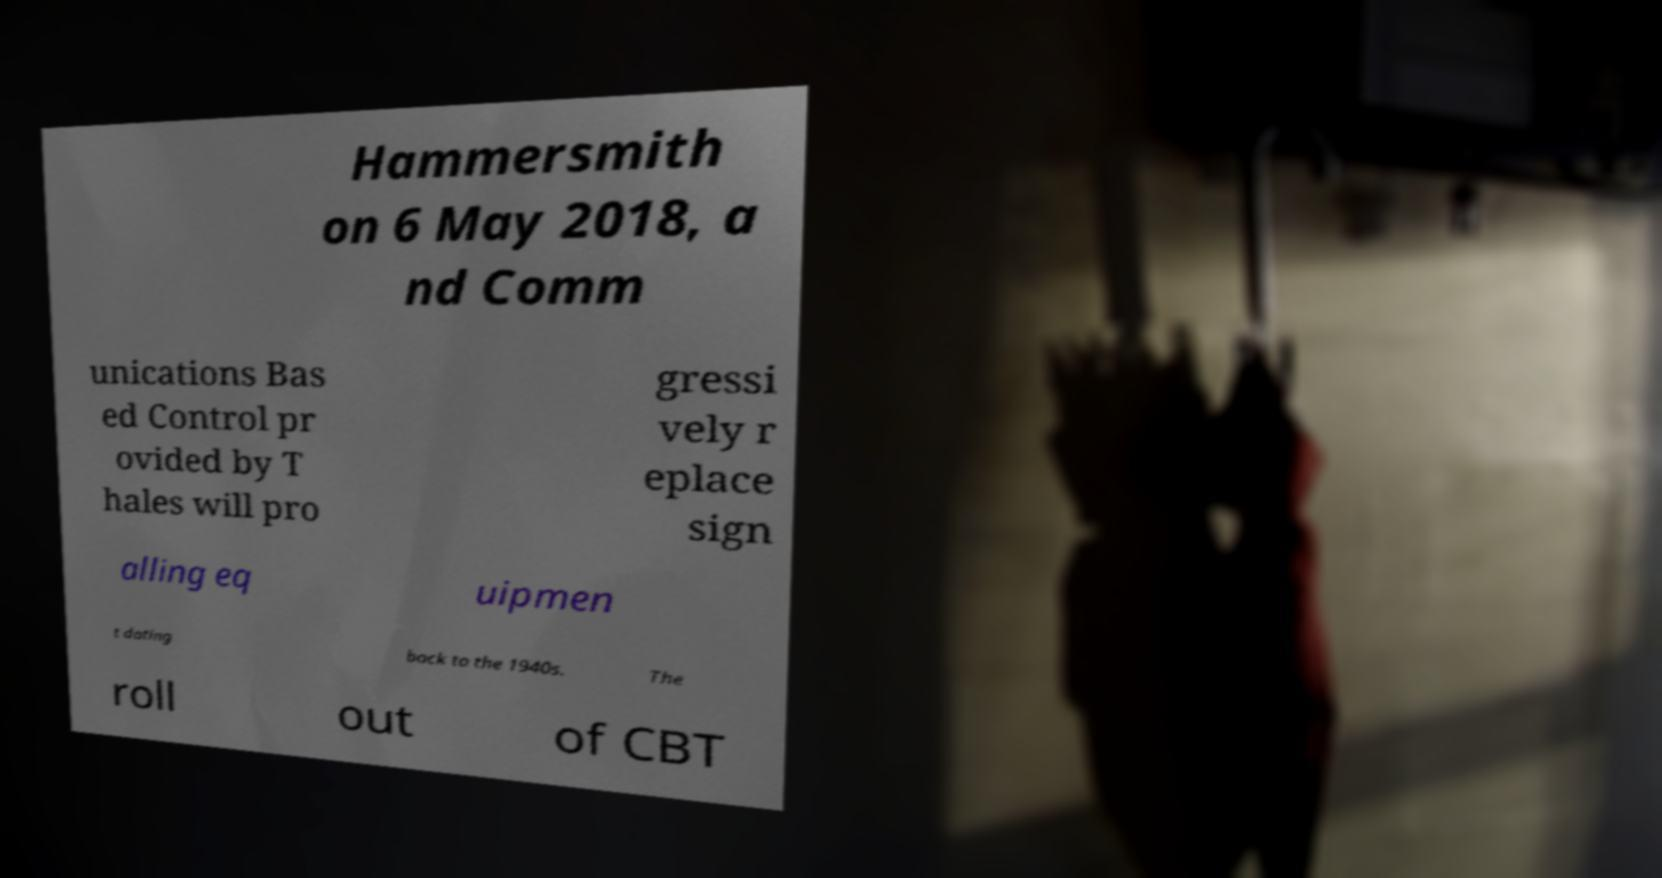Can you read and provide the text displayed in the image?This photo seems to have some interesting text. Can you extract and type it out for me? Hammersmith on 6 May 2018, a nd Comm unications Bas ed Control pr ovided by T hales will pro gressi vely r eplace sign alling eq uipmen t dating back to the 1940s. The roll out of CBT 